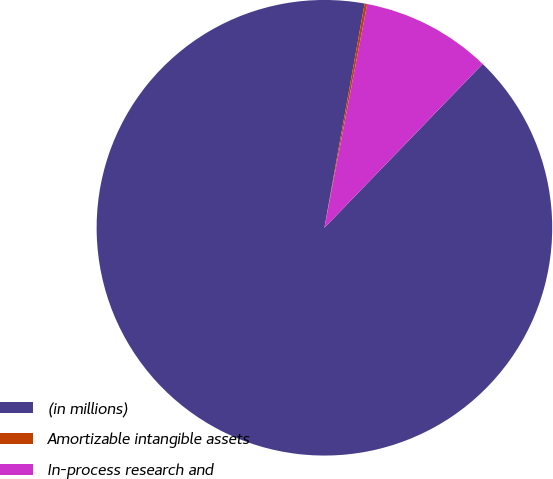Convert chart to OTSL. <chart><loc_0><loc_0><loc_500><loc_500><pie_chart><fcel>(in millions)<fcel>Amortizable intangible assets<fcel>In-process research and<nl><fcel>90.6%<fcel>0.18%<fcel>9.22%<nl></chart> 